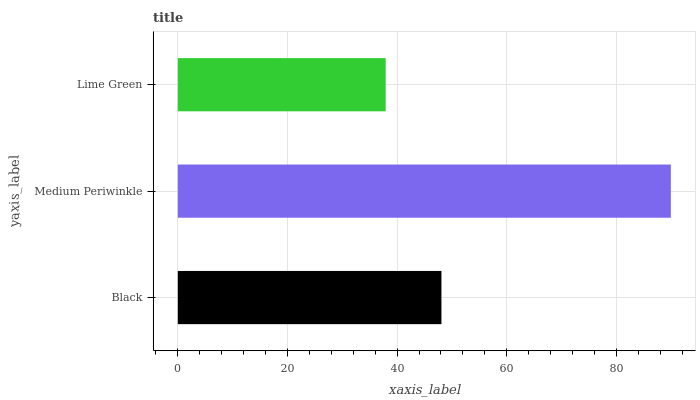Is Lime Green the minimum?
Answer yes or no. Yes. Is Medium Periwinkle the maximum?
Answer yes or no. Yes. Is Medium Periwinkle the minimum?
Answer yes or no. No. Is Lime Green the maximum?
Answer yes or no. No. Is Medium Periwinkle greater than Lime Green?
Answer yes or no. Yes. Is Lime Green less than Medium Periwinkle?
Answer yes or no. Yes. Is Lime Green greater than Medium Periwinkle?
Answer yes or no. No. Is Medium Periwinkle less than Lime Green?
Answer yes or no. No. Is Black the high median?
Answer yes or no. Yes. Is Black the low median?
Answer yes or no. Yes. Is Lime Green the high median?
Answer yes or no. No. Is Medium Periwinkle the low median?
Answer yes or no. No. 